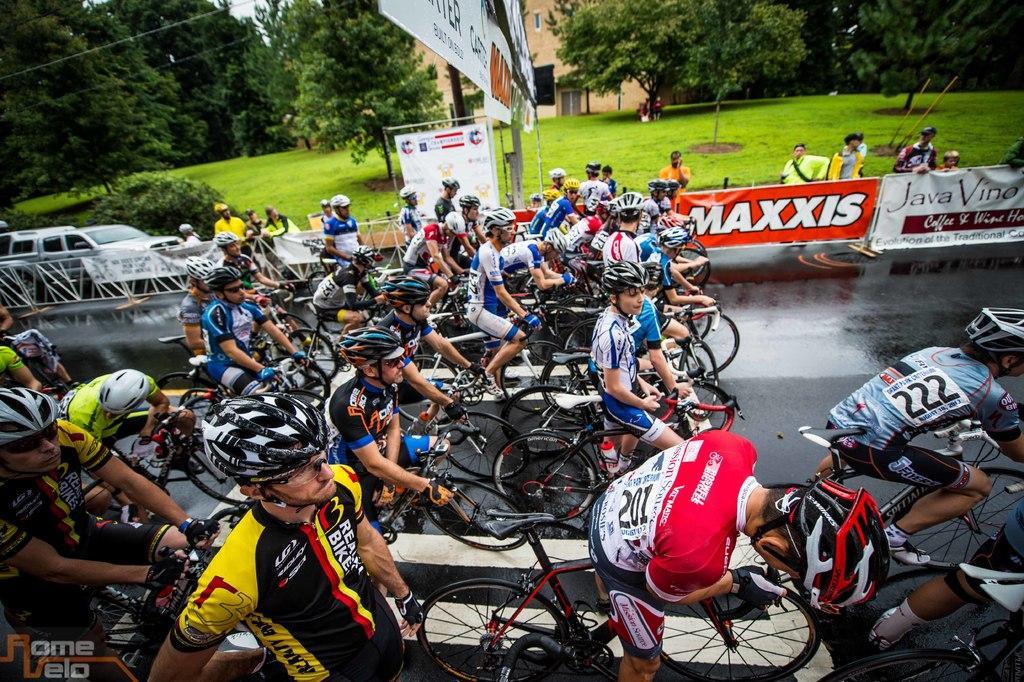How would you summarize this image in a sentence or two? This picture is clicked outside. In the foreground we can see the group of persons wearing helmets and seems to be riding bicycles, we can see a zebra crossing and we can see the text on the banners and we can see the metal rods, group of persons, green grass, vehicles, plants, trees, cable and a building and some other objects. 